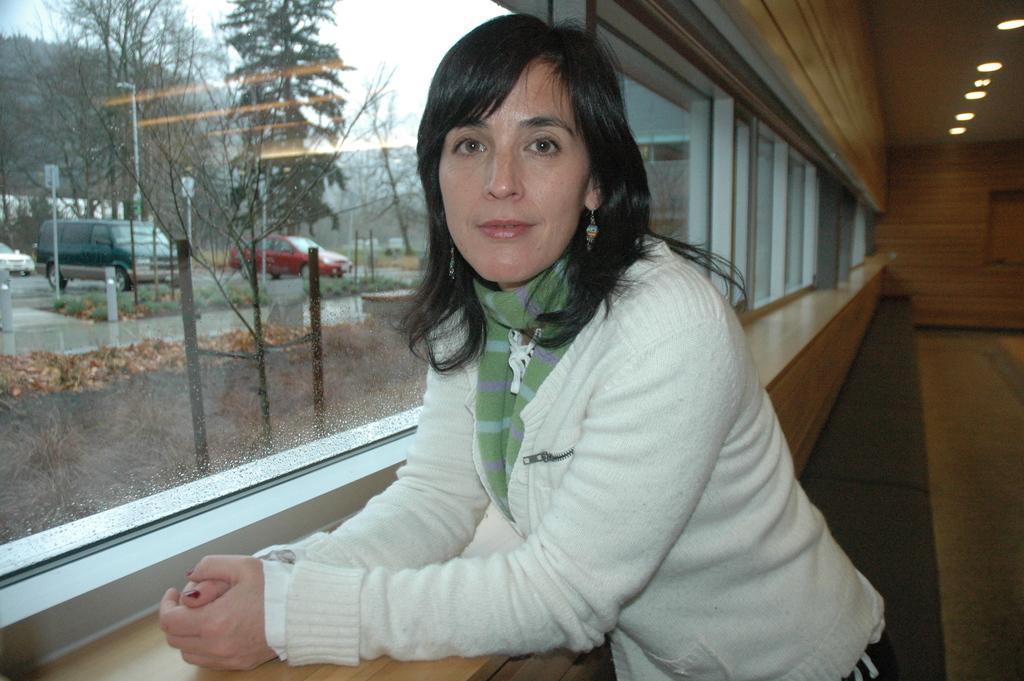How would you summarize this image in a sentence or two? In the image there is a woman posing for the photo in the foreground and beside her there are windows, in the background there is a wooden wall and behind the windows there are vehicles, trees and poles. 